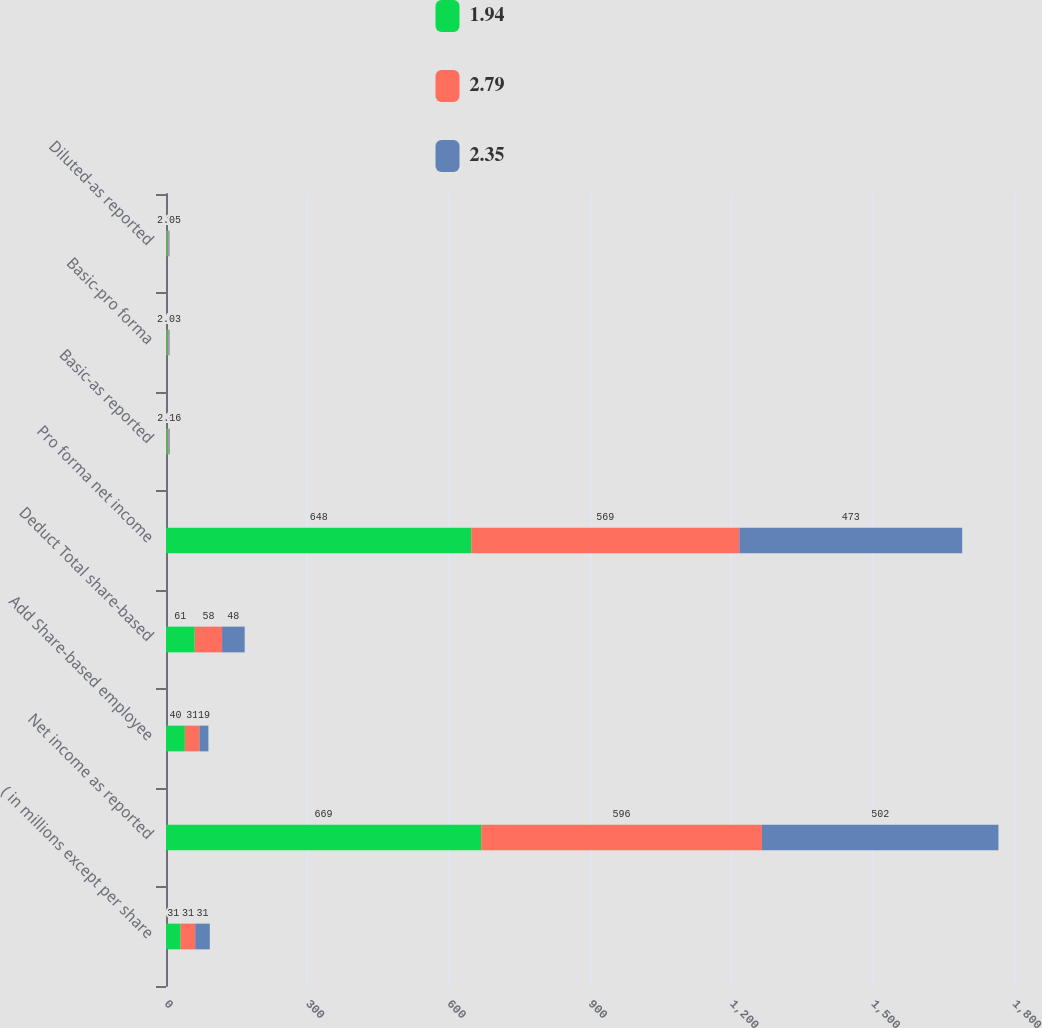Convert chart to OTSL. <chart><loc_0><loc_0><loc_500><loc_500><stacked_bar_chart><ecel><fcel>( in millions except per share<fcel>Net income as reported<fcel>Add Share-based employee<fcel>Deduct Total share-based<fcel>Pro forma net income<fcel>Basic-as reported<fcel>Basic-pro forma<fcel>Diluted-as reported<nl><fcel>1.94<fcel>31<fcel>669<fcel>40<fcel>61<fcel>648<fcel>3.09<fcel>2.99<fcel>2.89<nl><fcel>2.79<fcel>31<fcel>596<fcel>31<fcel>58<fcel>569<fcel>2.63<fcel>2.51<fcel>2.48<nl><fcel>2.35<fcel>31<fcel>502<fcel>19<fcel>48<fcel>473<fcel>2.16<fcel>2.03<fcel>2.05<nl></chart> 